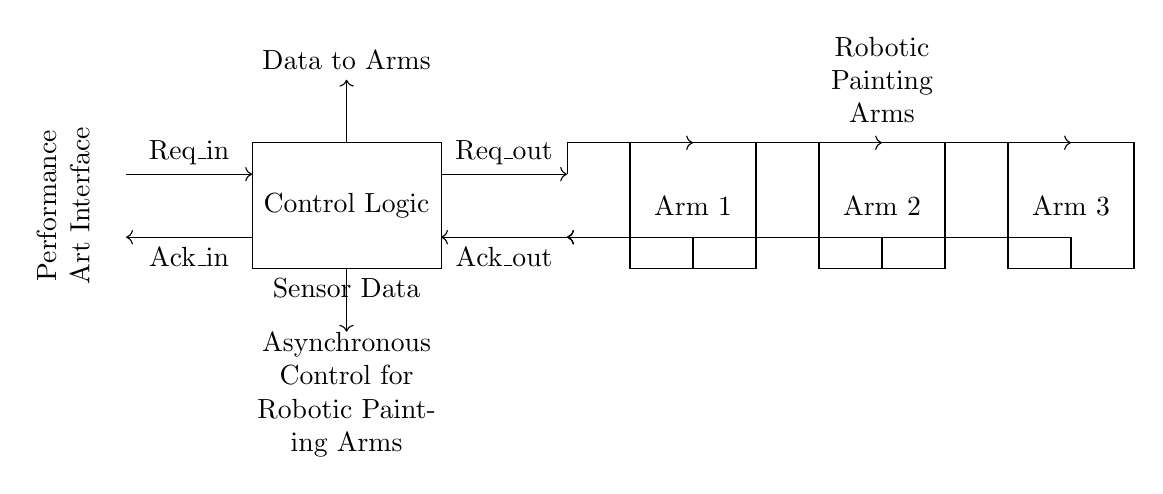What does the rectangle in the circuit diagram represent? The rectangle labeled "Control Logic" represents the main processing unit that governs the actions and operations of the circuit.
Answer: Control Logic How many robotic arms are connected in this circuit? There are three rectangles labeled "Arm 1", "Arm 2", and "Arm 3", indicating that the circuit controls three robotic arms.
Answer: Three What do the dashed lines represent in the circuit diagram? The dashed lines are used to represent the request and acknowledgment signals that enable communication between the control logic and the robotic arms.
Answer: Signals What is the purpose of the request and acknowledgment signals? The request signal indicates that the control logic wants to send data to the robotic arms, while the acknowledgment signal represents feedback confirming that the data has been received.
Answer: Communication What type of circuit is this diagram illustrating? This is an asynchronous circuit, as it utilizes handshake signals for communication without depending on a clock for synchronization among its components.
Answer: Asynchronous How does the circuit handle sensor data? The diagram shows a movement from "Sensor Data" into the control logic, which allows the circuit to process input from sensors related to the performance art setup.
Answer: Sensor input 